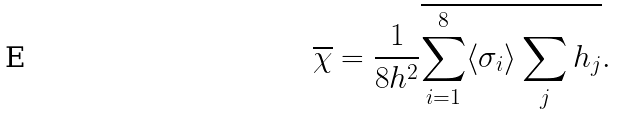<formula> <loc_0><loc_0><loc_500><loc_500>\overline { \chi } = \frac { 1 } { 8 h ^ { 2 } } \overline { \sum _ { i = 1 } ^ { 8 } \langle \sigma _ { i } \rangle \sum _ { j } h _ { j } } .</formula> 